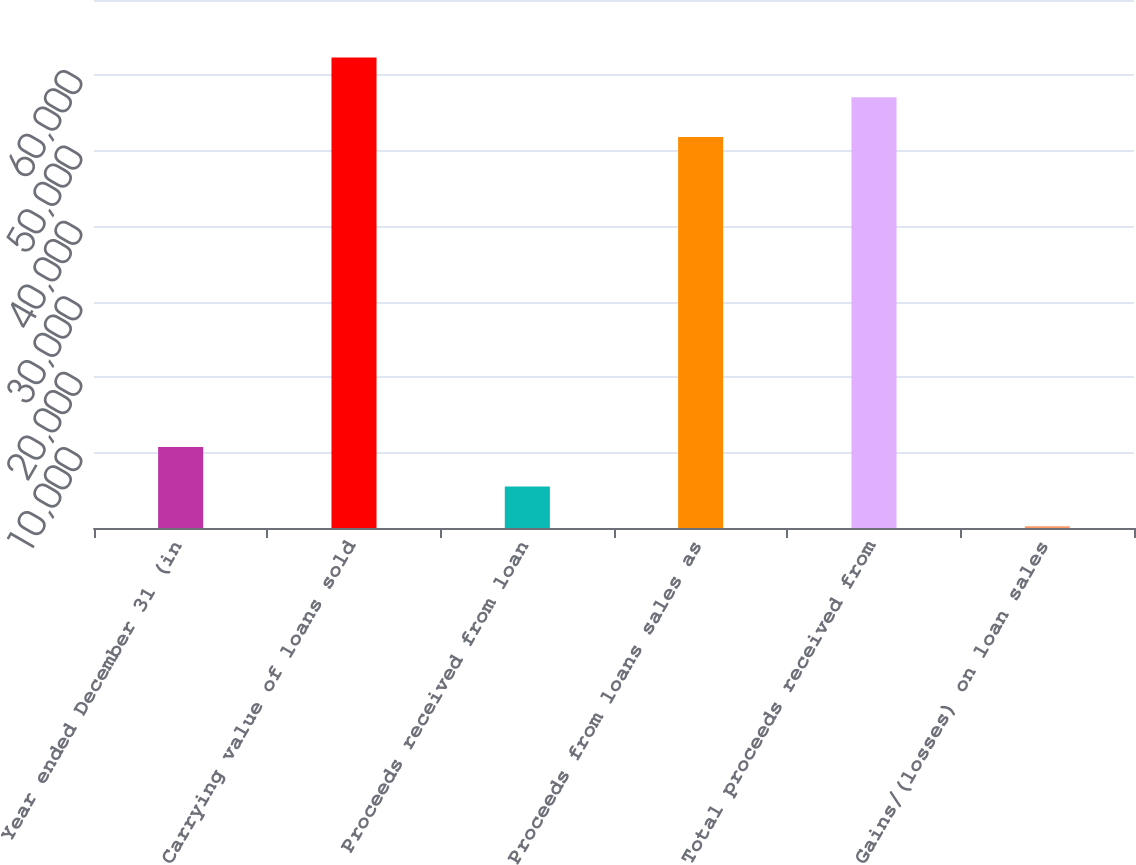<chart> <loc_0><loc_0><loc_500><loc_500><bar_chart><fcel>Year ended December 31 (in<fcel>Carrying value of loans sold<fcel>Proceeds received from loan<fcel>Proceeds from loans sales as<fcel>Total proceeds received from<fcel>Gains/(losses) on loan sales<nl><fcel>10751.4<fcel>62381.4<fcel>5486.7<fcel>51852<fcel>57116.7<fcel>222<nl></chart> 